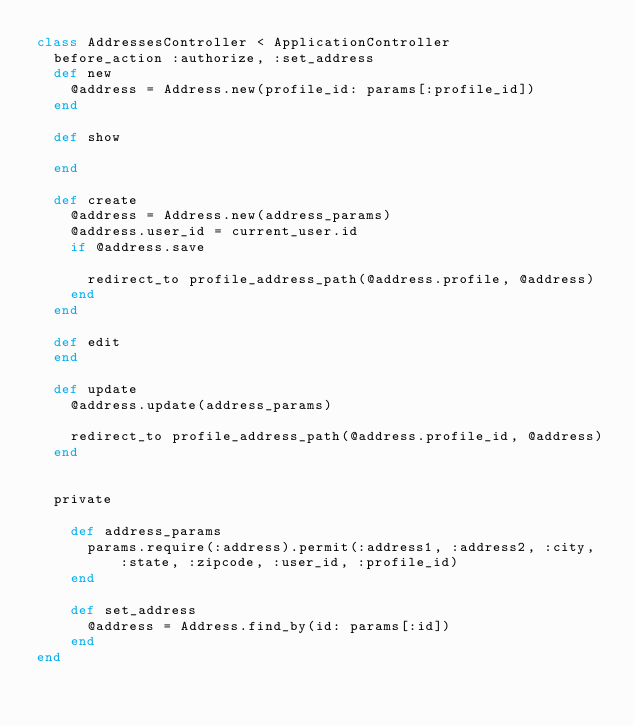<code> <loc_0><loc_0><loc_500><loc_500><_Ruby_>class AddressesController < ApplicationController
  before_action :authorize, :set_address
  def new
    @address = Address.new(profile_id: params[:profile_id])
  end

  def show

  end

  def create
    @address = Address.new(address_params)
    @address.user_id = current_user.id
    if @address.save

      redirect_to profile_address_path(@address.profile, @address)
    end
  end

  def edit
  end

  def update
    @address.update(address_params)

    redirect_to profile_address_path(@address.profile_id, @address)
  end


  private

    def address_params
      params.require(:address).permit(:address1, :address2, :city, :state, :zipcode, :user_id, :profile_id)
    end

    def set_address
      @address = Address.find_by(id: params[:id])
    end
end
</code> 